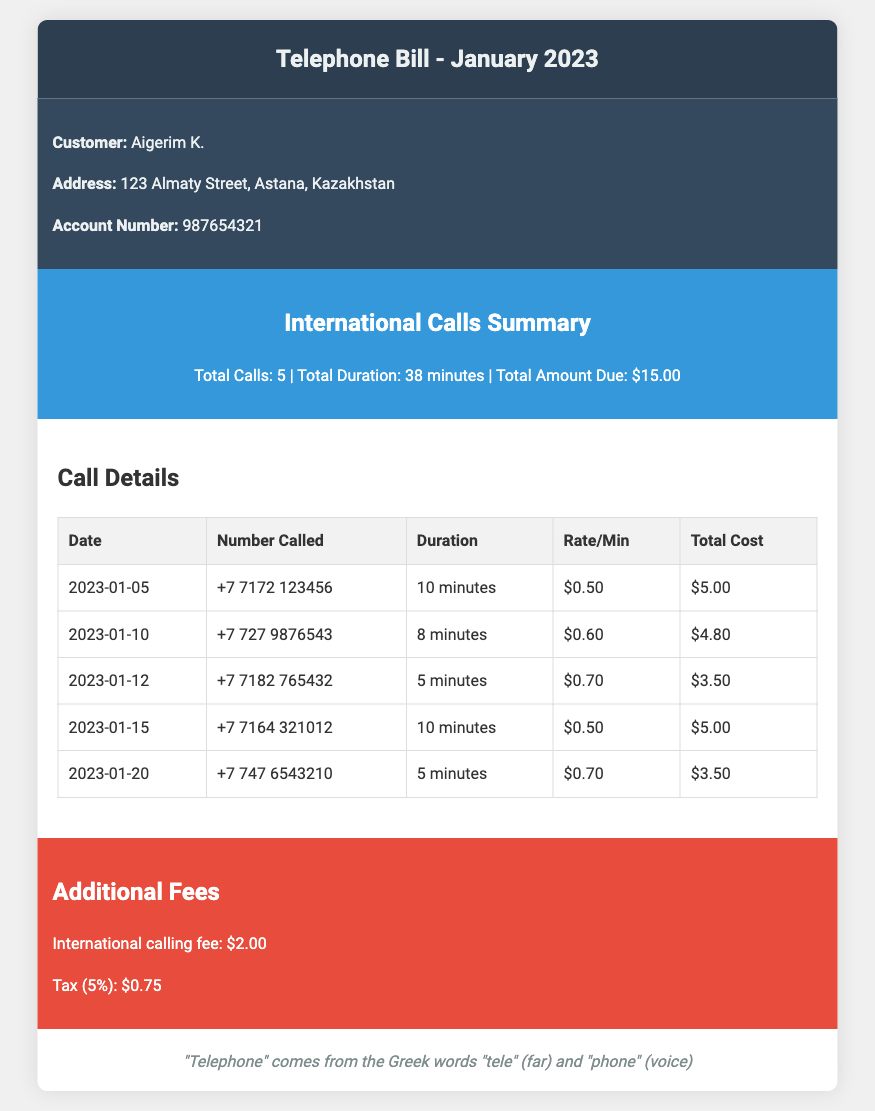What is the total amount due? The total amount due is mentioned in the summary section as $15.00.
Answer: $15.00 How many international calls were made? The summary section indicates that there were 5 international calls made.
Answer: 5 What was the duration of the longest call? The call details section shows that the longest call was 10 minutes long on two occasions.
Answer: 10 minutes What is the rate per minute for the call on January 10? The call details reveal that the rate per minute for the call on January 10 is $0.60.
Answer: $0.60 What is the international calling fee? The additional fees section specifies the international calling fee as $2.00.
Answer: $2.00 What is the total tax applied? The additional fees section indicates that the tax applied is 5%, amounting to $0.75.
Answer: $0.75 Which number was called on January 12? The call details section lists the number called on January 12 as +7 7182 765432.
Answer: +7 7182 765432 What is the name of the customer? The customer information section identifies the customer's name as Aigerim K.
Answer: Aigerim K What is the date of the first international call? The call details section shows that the first international call was made on January 5, 2023.
Answer: 2023-01-05 